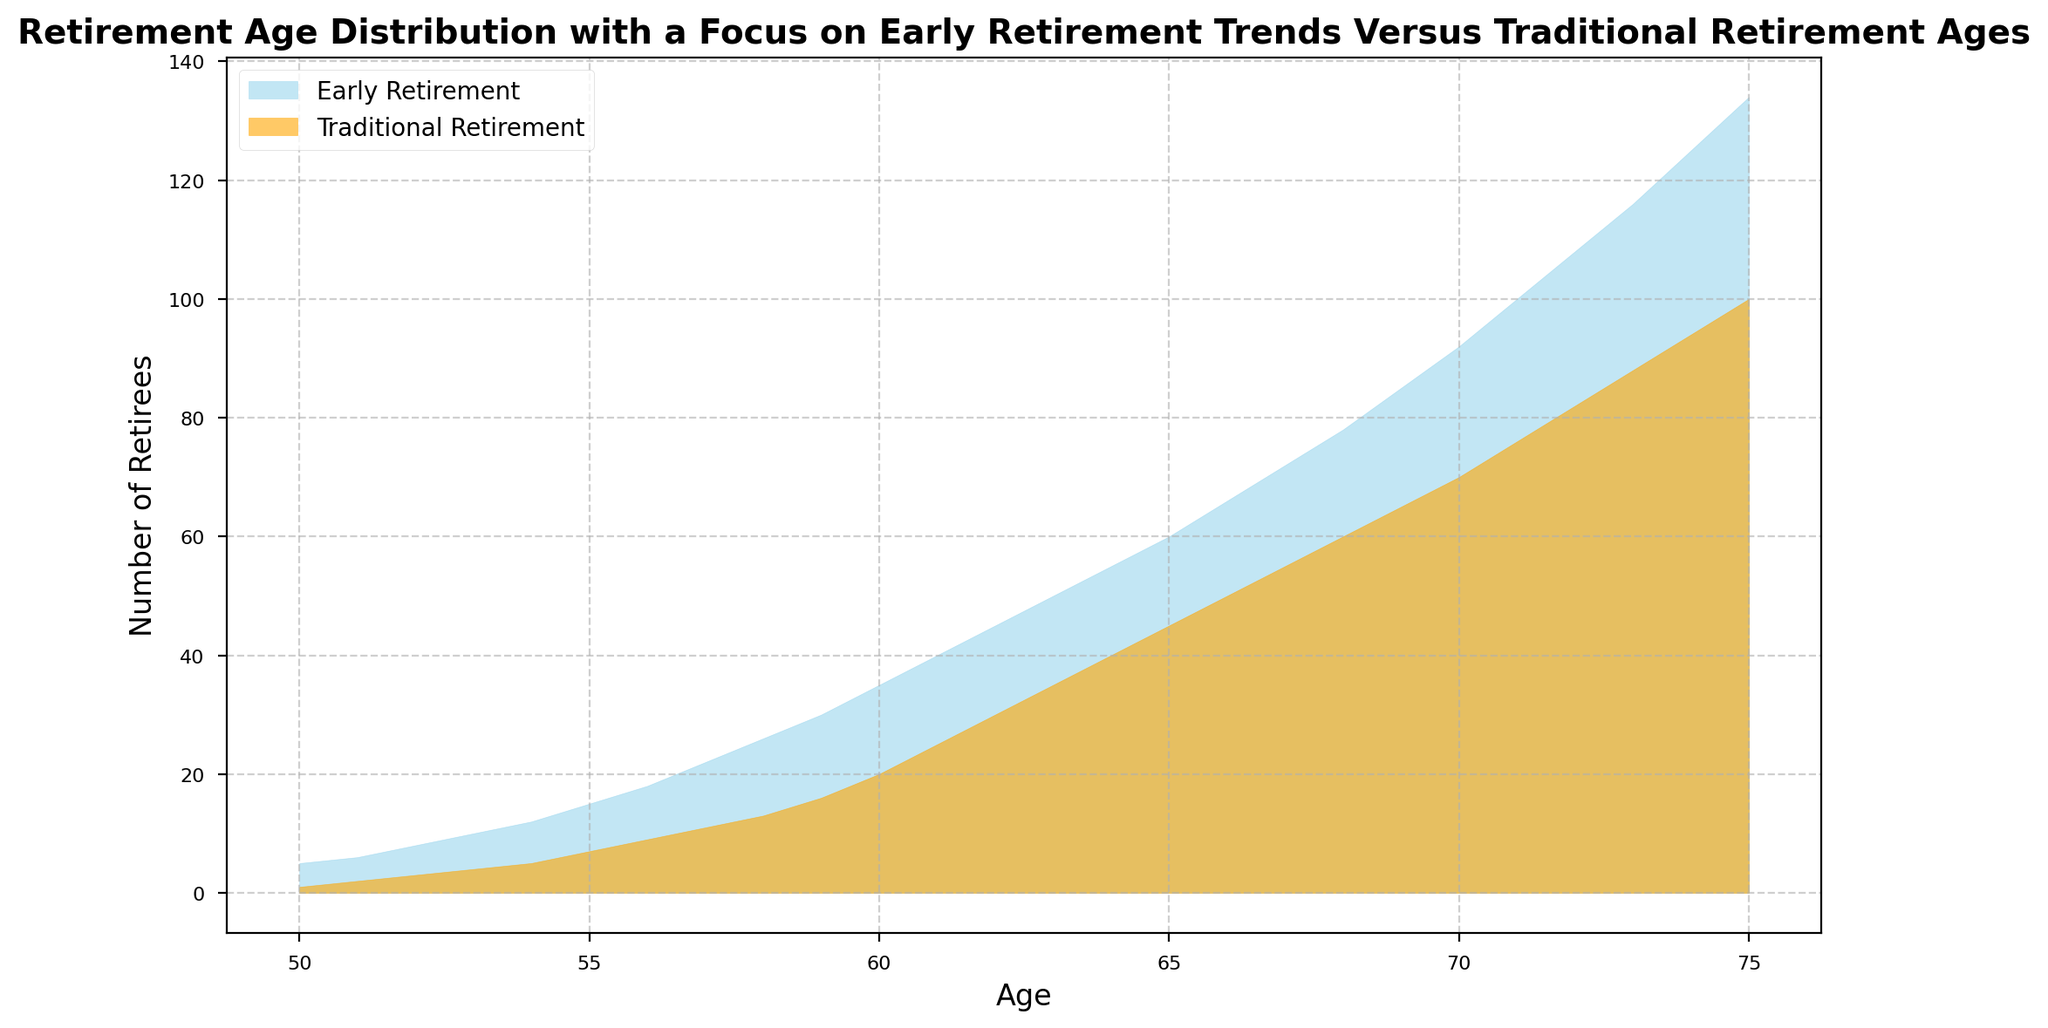What is the range of ages depicted in the figure? The x-axis labels represent the ages from 50 to 75, indicating the range of ages shown.
Answer: 50 to 75 At age 55, how many more people retired early compared to those who retired traditionally? At age 55, the number of early retirees is 15 and the number of traditional retirees is 7. Subtract 7 from 15. The difference is 15 - 7 = 8.
Answer: 8 Which age has the maximum number of traditional retirees? Reviewing the traditional retirement section of the chart, the highest peak occurs at age 75 with 100 retirees.
Answer: 75 How does the number of early retirees at age 60 compare to the number of traditional retirees at the same age? At age 60, early retirees numbered 35 and traditional retirees numbered 20. Comparing the two numbers, 35 is greater than 20.
Answer: More for Early Retirees What is the trend of early retirements as people age from 50 to 70? Observing the early retirement area, we see an increasing trend as the numbers rise from 5 at age 50 to 92 at age 70.
Answer: Increasing If you add up the number of early retirees from ages 50 to 55, what is the total? Adding up the early retirees from ages 50 (5), 51 (6), 52 (8), 53 (10), 54 (12), and 55 (15), we get 5 + 6 + 8 + 10 + 12 + 15 = 56.
Answer: 56 Which group has a wider area under the curve, early retirees or traditional retirees, by age 70? Visually comparing the two areas under the curve up to age 70, the early retirement area is significantly larger, indicating a higher number of early retirees.
Answer: Early Retirees What noticeable pattern do you see comparing early and traditional retirements from ages 66 to 75? From ages 66 to 75, the early retirement numbers generally continue to rise, while traditional retirements also increase but at a lower rate, creating a noticeable gap between the two areas.
Answer: Increasing gap How many total retirees are there at age 72 when combining both early and traditional retirements? At age 72, early retirees are 108 and traditional retirees are 82. Adding these together gives 108 + 82 = 190.
Answer: 190 